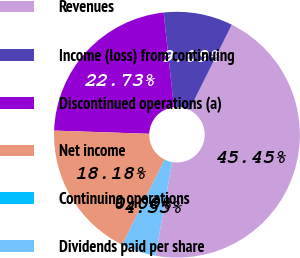Convert chart. <chart><loc_0><loc_0><loc_500><loc_500><pie_chart><fcel>Revenues<fcel>Income (loss) from continuing<fcel>Discontinued operations (a)<fcel>Net income<fcel>Continuing operations<fcel>Dividends paid per share<nl><fcel>45.45%<fcel>9.09%<fcel>22.73%<fcel>18.18%<fcel>0.0%<fcel>4.55%<nl></chart> 